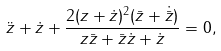Convert formula to latex. <formula><loc_0><loc_0><loc_500><loc_500>\ddot { z } + \dot { z } + \frac { 2 ( z + \dot { z } ) ^ { 2 } ( \bar { z } + \dot { \bar { z } } ) } { z \bar { z } + \bar { z } \dot { z } + \dot { z } } = 0 ,</formula> 